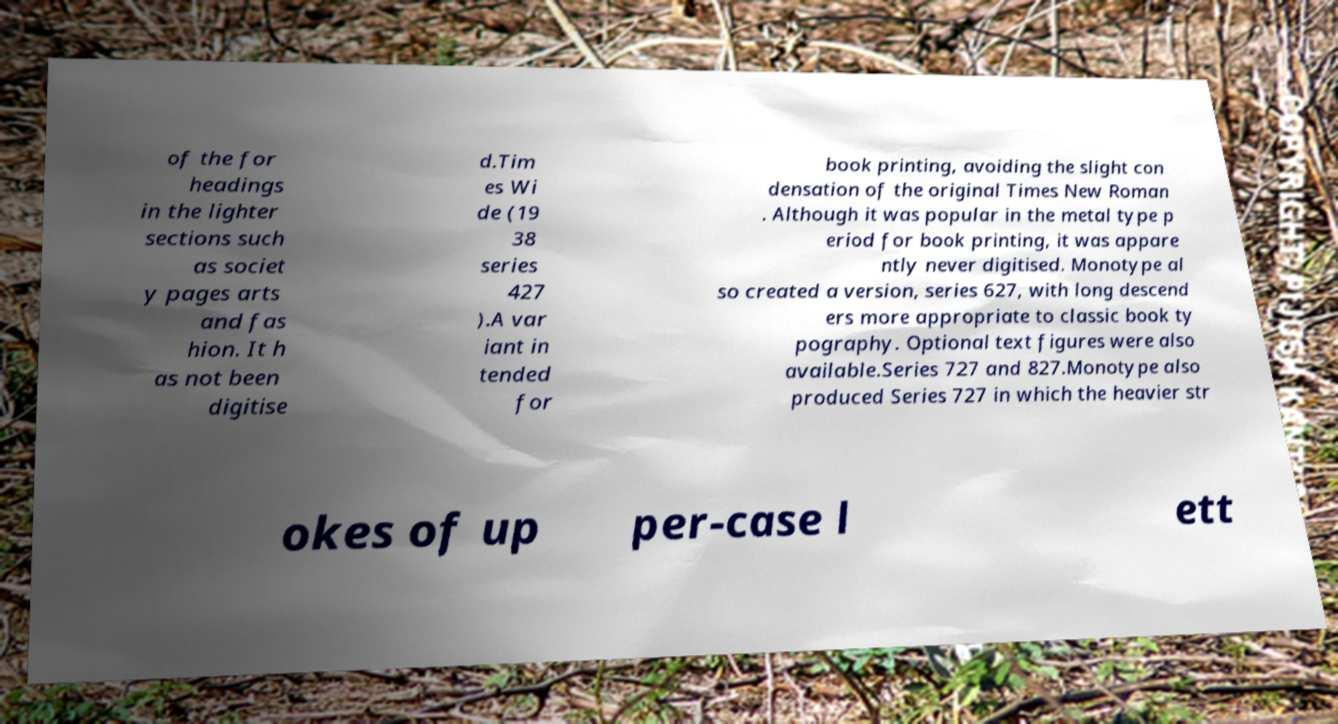Can you accurately transcribe the text from the provided image for me? of the for headings in the lighter sections such as societ y pages arts and fas hion. It h as not been digitise d.Tim es Wi de (19 38 series 427 ).A var iant in tended for book printing, avoiding the slight con densation of the original Times New Roman . Although it was popular in the metal type p eriod for book printing, it was appare ntly never digitised. Monotype al so created a version, series 627, with long descend ers more appropriate to classic book ty pography. Optional text figures were also available.Series 727 and 827.Monotype also produced Series 727 in which the heavier str okes of up per-case l ett 